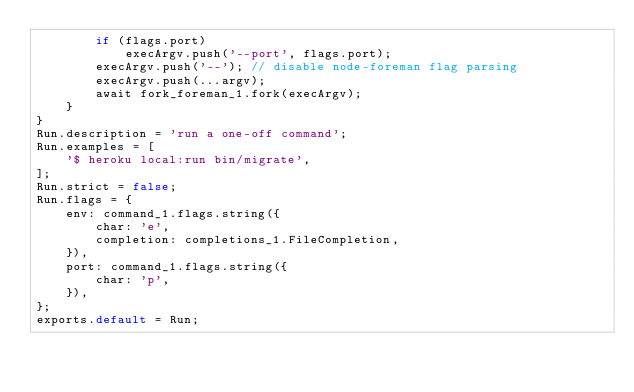Convert code to text. <code><loc_0><loc_0><loc_500><loc_500><_JavaScript_>        if (flags.port)
            execArgv.push('--port', flags.port);
        execArgv.push('--'); // disable node-foreman flag parsing
        execArgv.push(...argv);
        await fork_foreman_1.fork(execArgv);
    }
}
Run.description = 'run a one-off command';
Run.examples = [
    '$ heroku local:run bin/migrate',
];
Run.strict = false;
Run.flags = {
    env: command_1.flags.string({
        char: 'e',
        completion: completions_1.FileCompletion,
    }),
    port: command_1.flags.string({
        char: 'p',
    }),
};
exports.default = Run;
</code> 